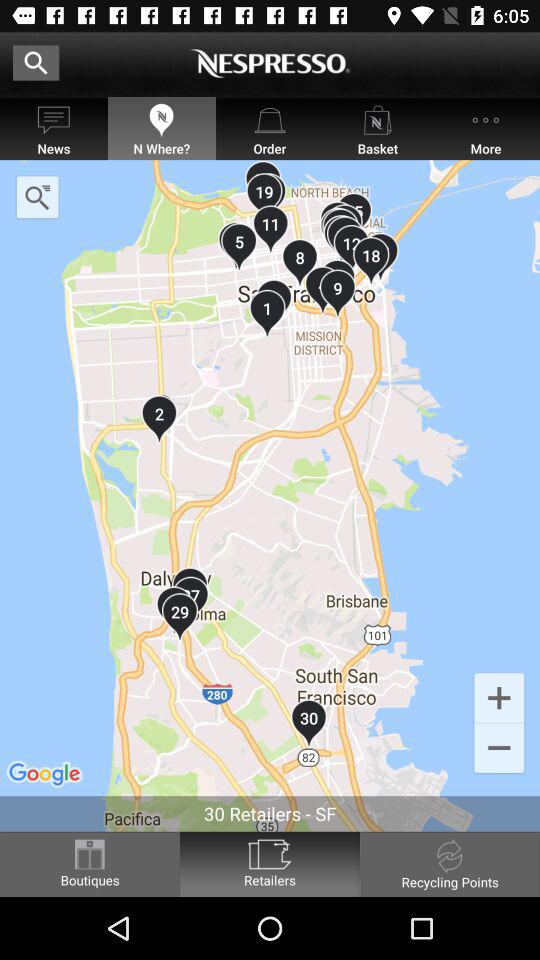What is the name of the application? The name of the application is "NESPRESSO". 